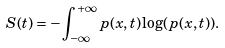Convert formula to latex. <formula><loc_0><loc_0><loc_500><loc_500>S ( t ) = - \int _ { - \infty } ^ { + \infty } p ( x , t ) \log ( p ( x , t ) ) .</formula> 